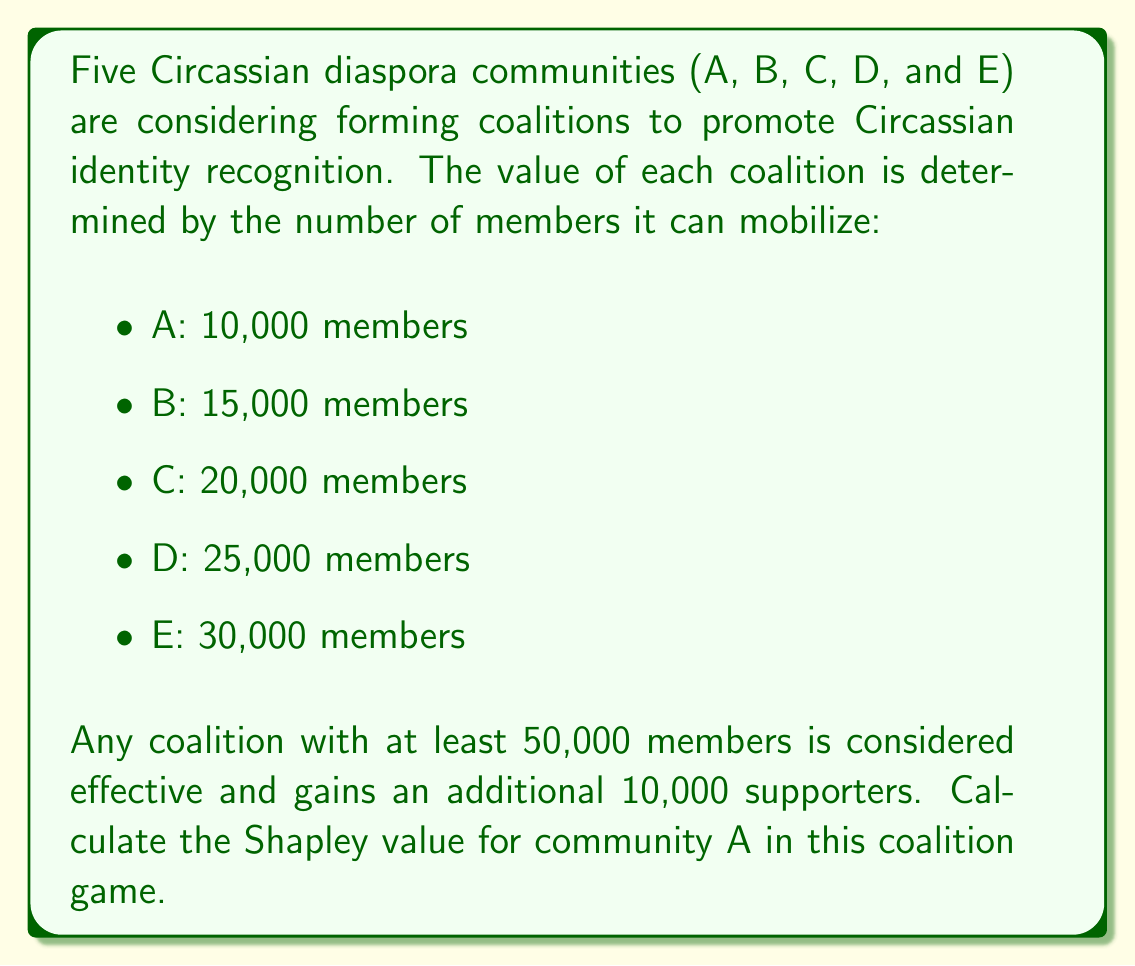What is the answer to this math problem? To calculate the Shapley value for community A, we need to determine its marginal contribution in all possible coalition formations. Let's follow these steps:

1) First, list all possible coalitions containing A:
   {A}, {A,B}, {A,C}, {A,D}, {A,E}, {A,B,C}, {A,B,D}, {A,B,E}, {A,C,D}, {A,C,E}, {A,D,E}, {A,B,C,D}, {A,B,C,E}, {A,B,D,E}, {A,C,D,E}, {A,B,C,D,E}

2) Calculate the value of each coalition:
   - Coalitions with < 50,000 members: Sum of individual members
   - Coalitions with ≥ 50,000 members: Sum of individual members + 10,000

3) Calculate A's marginal contribution in each ordering:
   - (A): 10,000
   - (A,B): 10,000
   - (A,C): 10,000
   - (A,D): 10,000
   - (A,E): 10,000
   - (B,A): 10,000
   - (C,A): 10,000
   - (D,A): 10,000
   - (E,A): 10,000
   - (B,C,A): 10,000
   - (B,D,A): 10,000
   - (B,E,A): 10,000
   - (C,D,A): 10,000
   - (C,E,A): 10,000
   - (D,E,A): 0
   - (C,B,A): 10,000
   - (D,B,A): 10,000
   - (E,B,A): 10,000
   - (D,C,A): 10,000
   - (E,C,A): 0
   - (E,D,A): 0
   - (B,C,D,A): 10,000
   - (B,C,E,A): 0
   - (B,D,E,A): 0
   - (C,D,E,A): 0
   - (C,B,D,A): 10,000
   - (C,B,E,A): 0
   - (D,B,E,A): 0
   - (D,C,E,A): 0
   - (E,B,C,A): 0
   - (E,B,D,A): 0
   - (E,C,D,A): 0
   - (B,C,D,E,A): 0
   - (B,C,E,D,A): 0
   - (B,D,C,E,A): 0
   - (B,D,E,C,A): 0
   - (B,E,C,D,A): 0
   - (B,E,D,C,A): 0
   - (C,B,D,E,A): 0
   - (C,B,E,D,A): 0
   - (C,D,B,E,A): 0
   - (C,D,E,B,A): 0
   - (C,E,B,D,A): 0
   - (C,E,D,B,A): 0
   - (D,B,C,E,A): 0
   - (D,B,E,C,A): 0
   - (D,C,B,E,A): 0
   - (D,C,E,B,A): 0
   - (D,E,B,C,A): 0
   - (D,E,C,B,A): 0
   - (E,B,C,D,A): 0
   - (E,B,D,C,A): 0
   - (E,C,B,D,A): 0
   - (E,C,D,B,A): 0
   - (E,D,B,C,A): 0
   - (E,D,C,B,A): 0

4) Calculate the Shapley value:
   
   $$\phi_A = \frac{1}{5!} \sum_{i=1}^{5!} MC_i(A)$$

   Where $MC_i(A)$ is the marginal contribution of A in the i-th permutation.

5) Sum up all marginal contributions and divide by 120 (5!):

   $$\phi_A = \frac{200,000}{120} = \frac{5000}{3} \approx 1,666.67$$
Answer: The Shapley value for community A is $\frac{5000}{3}$ or approximately 1,666.67. 